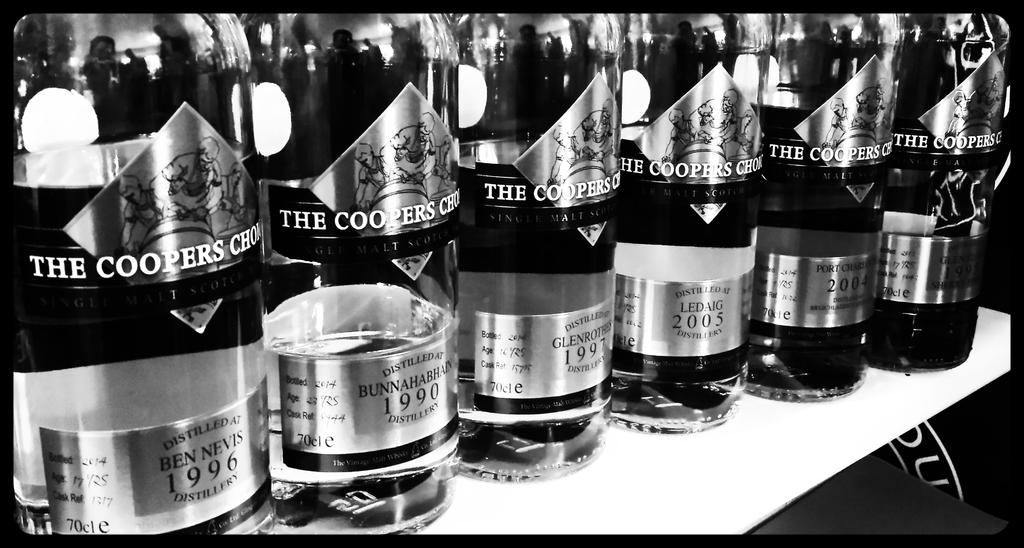<image>
Render a clear and concise summary of the photo. Several bottles of alcohol with dates including 1990 and 1997 are lined up. 